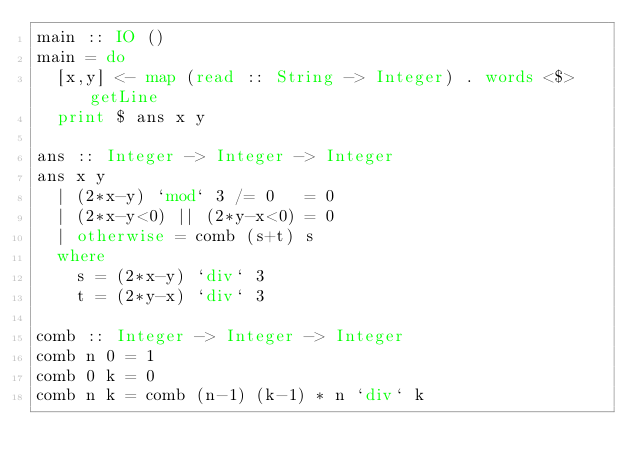<code> <loc_0><loc_0><loc_500><loc_500><_Haskell_>main :: IO ()
main = do
  [x,y] <- map (read :: String -> Integer) . words <$> getLine
  print $ ans x y

ans :: Integer -> Integer -> Integer
ans x y
  | (2*x-y) `mod` 3 /= 0   = 0
  | (2*x-y<0) || (2*y-x<0) = 0
  | otherwise = comb (s+t) s
  where
    s = (2*x-y) `div` 3
    t = (2*y-x) `div` 3

comb :: Integer -> Integer -> Integer
comb n 0 = 1
comb 0 k = 0
comb n k = comb (n-1) (k-1) * n `div` k</code> 